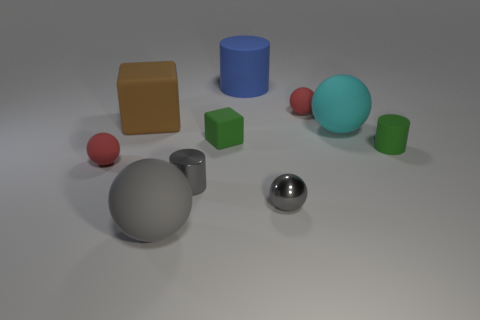Subtract all cyan balls. How many balls are left? 4 Subtract all gray shiny spheres. How many spheres are left? 4 Subtract all purple balls. Subtract all green cylinders. How many balls are left? 5 Subtract all cylinders. How many objects are left? 7 Subtract 0 red cubes. How many objects are left? 10 Subtract all gray spheres. Subtract all big yellow shiny objects. How many objects are left? 8 Add 7 gray objects. How many gray objects are left? 10 Add 4 tiny green rubber cylinders. How many tiny green rubber cylinders exist? 5 